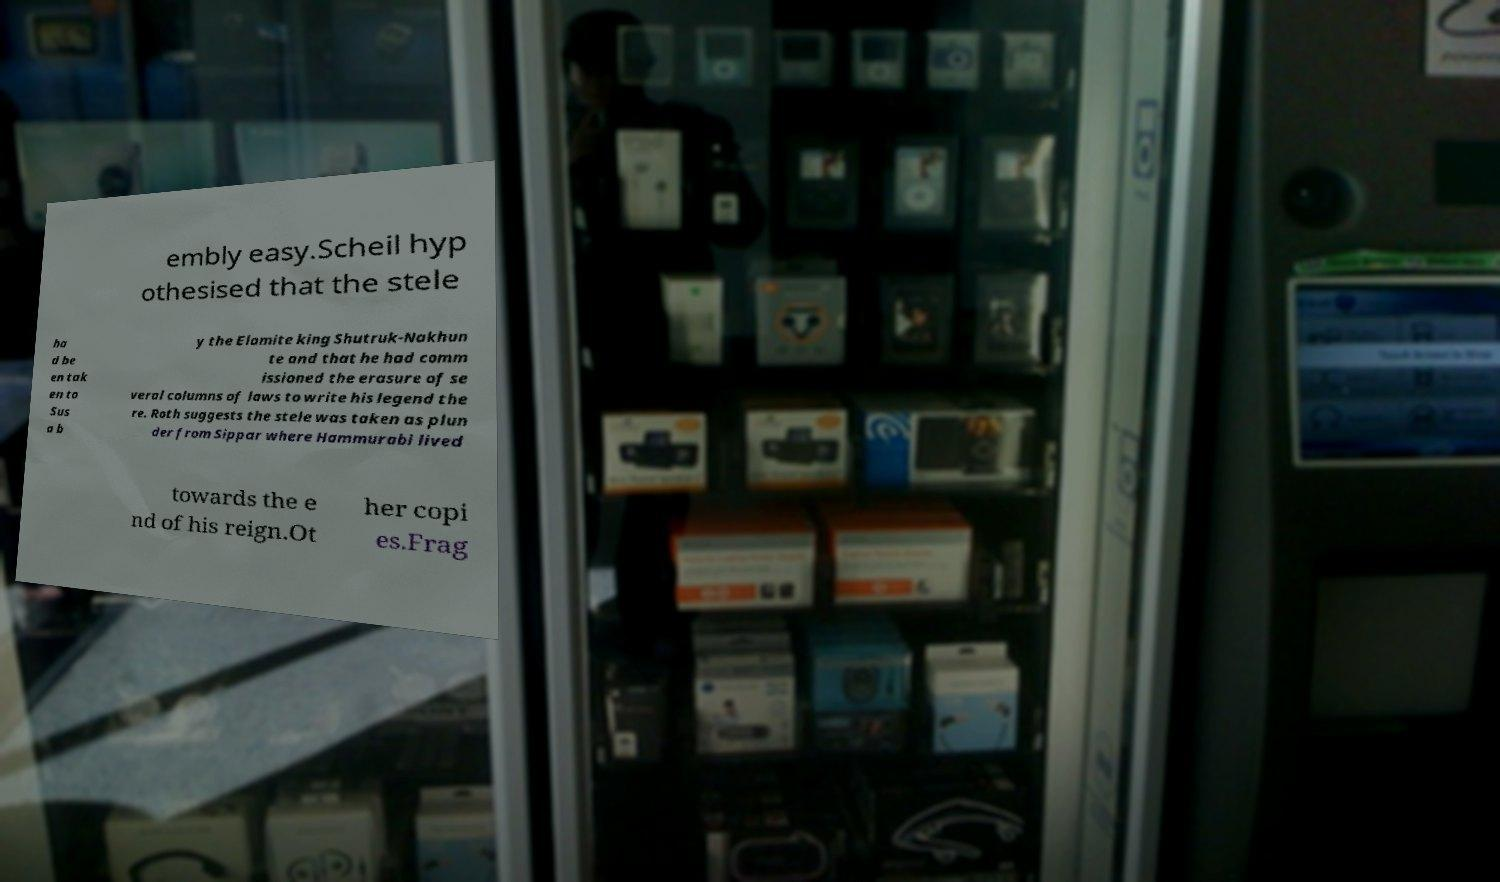Please read and relay the text visible in this image. What does it say? embly easy.Scheil hyp othesised that the stele ha d be en tak en to Sus a b y the Elamite king Shutruk-Nakhun te and that he had comm issioned the erasure of se veral columns of laws to write his legend the re. Roth suggests the stele was taken as plun der from Sippar where Hammurabi lived towards the e nd of his reign.Ot her copi es.Frag 